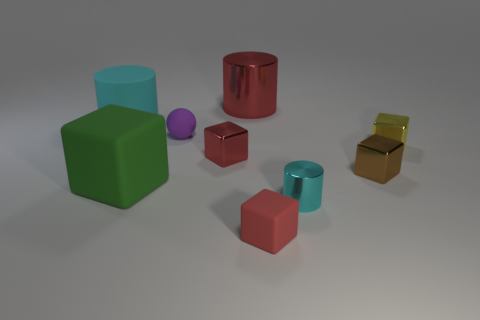Is there anything else that has the same size as the red cylinder?
Offer a very short reply. Yes. Are there any other cylinders that have the same color as the large matte cylinder?
Provide a succinct answer. Yes. Does the metal cylinder to the right of the big red cylinder have the same color as the big thing to the left of the big block?
Offer a very short reply. Yes. Do the red thing in front of the large block and the small brown thing have the same material?
Provide a short and direct response. No. Are any blue rubber cylinders visible?
Offer a terse response. No. How big is the matte object that is both in front of the brown thing and to the left of the small purple ball?
Your response must be concise. Large. Are there more tiny red cubes in front of the brown metallic cube than large matte things that are right of the cyan matte cylinder?
Your answer should be very brief. No. There is a metallic block that is the same color as the big shiny object; what size is it?
Your answer should be very brief. Small. The tiny rubber block has what color?
Provide a succinct answer. Red. There is a big object that is in front of the large shiny thing and behind the tiny purple matte ball; what color is it?
Your answer should be very brief. Cyan. 